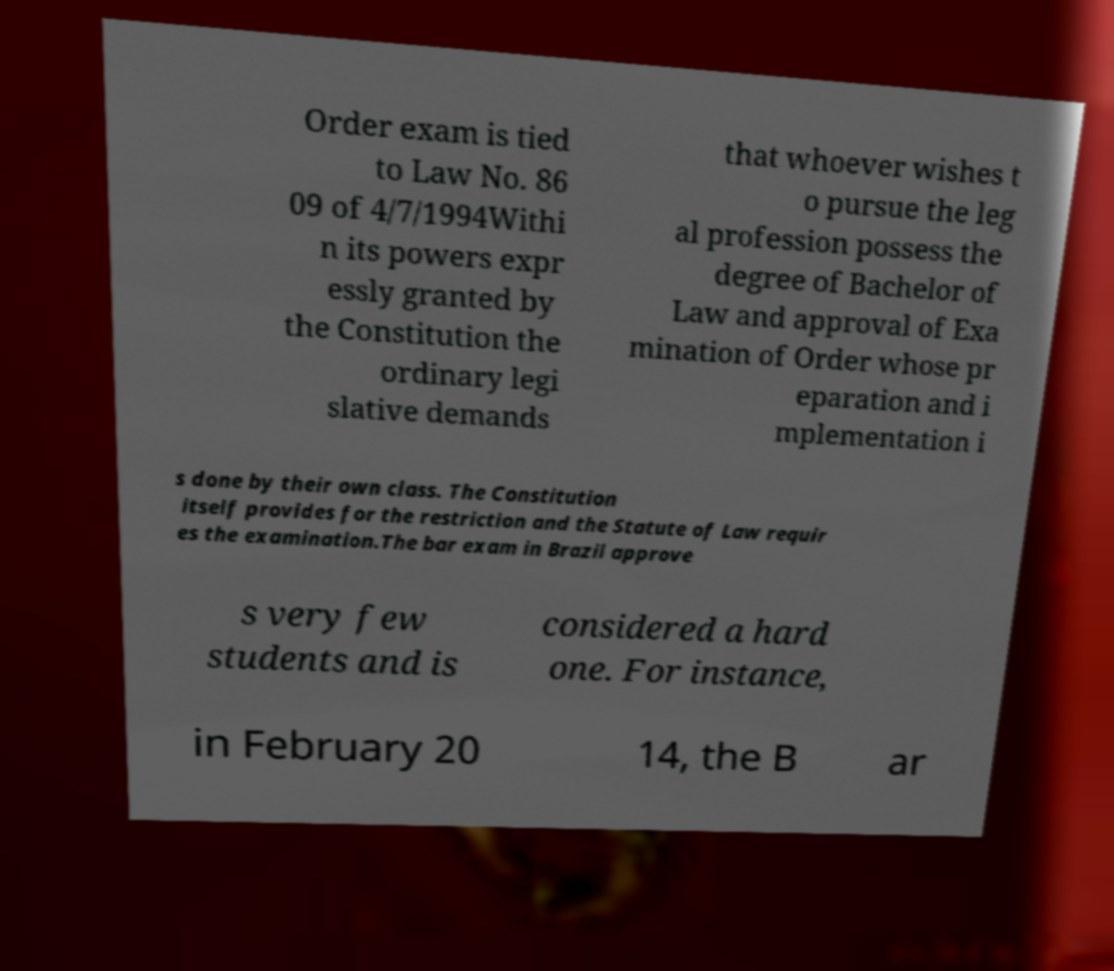I need the written content from this picture converted into text. Can you do that? Order exam is tied to Law No. 86 09 of 4/7/1994Withi n its powers expr essly granted by the Constitution the ordinary legi slative demands that whoever wishes t o pursue the leg al profession possess the degree of Bachelor of Law and approval of Exa mination of Order whose pr eparation and i mplementation i s done by their own class. The Constitution itself provides for the restriction and the Statute of Law requir es the examination.The bar exam in Brazil approve s very few students and is considered a hard one. For instance, in February 20 14, the B ar 